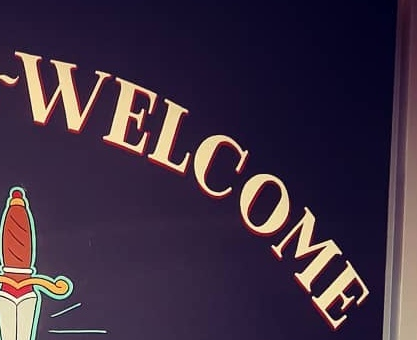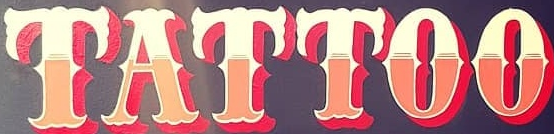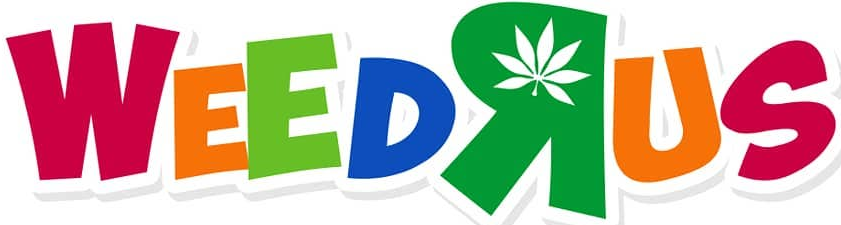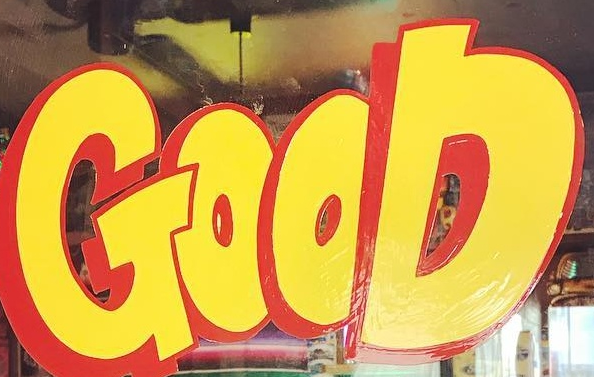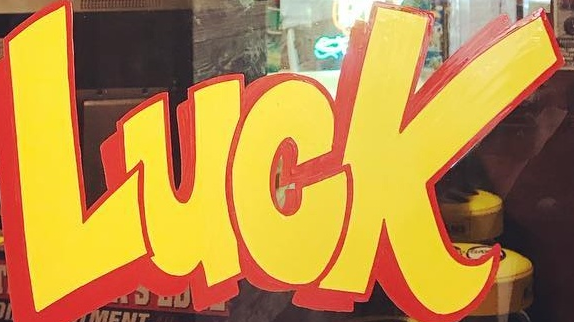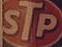What words can you see in these images in sequence, separated by a semicolon? WELCOME; TATTOO; WEEDRUS; GOOD; LUCK; STP 